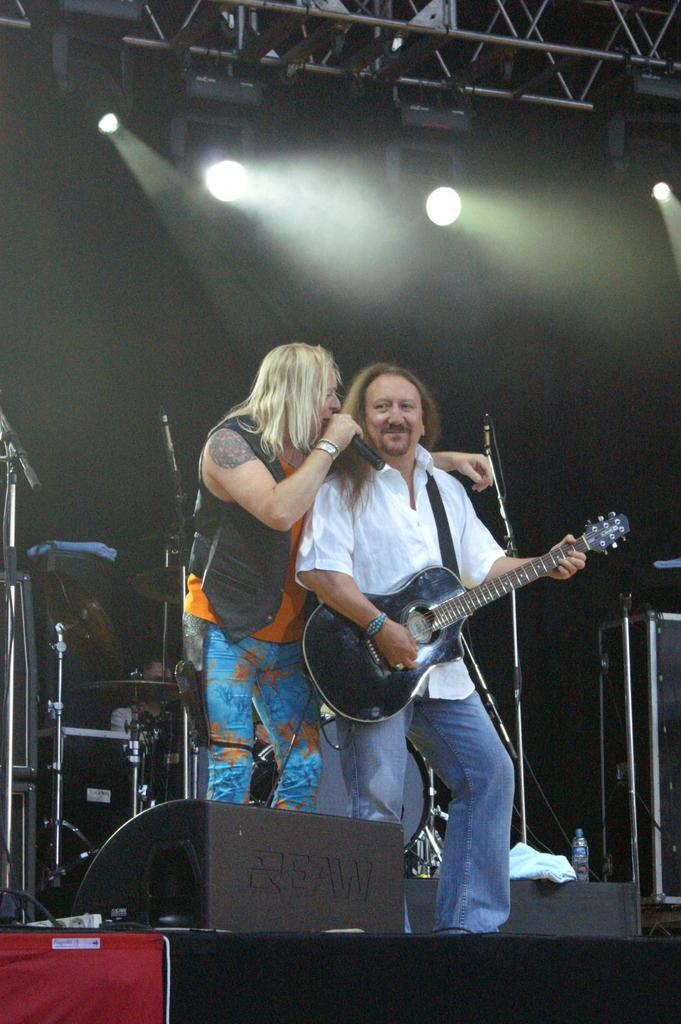Can you describe this image briefly? As we can see in the image there are two people on stage. One man is holding mic in his hand and other man is holding guitar in his hand. 